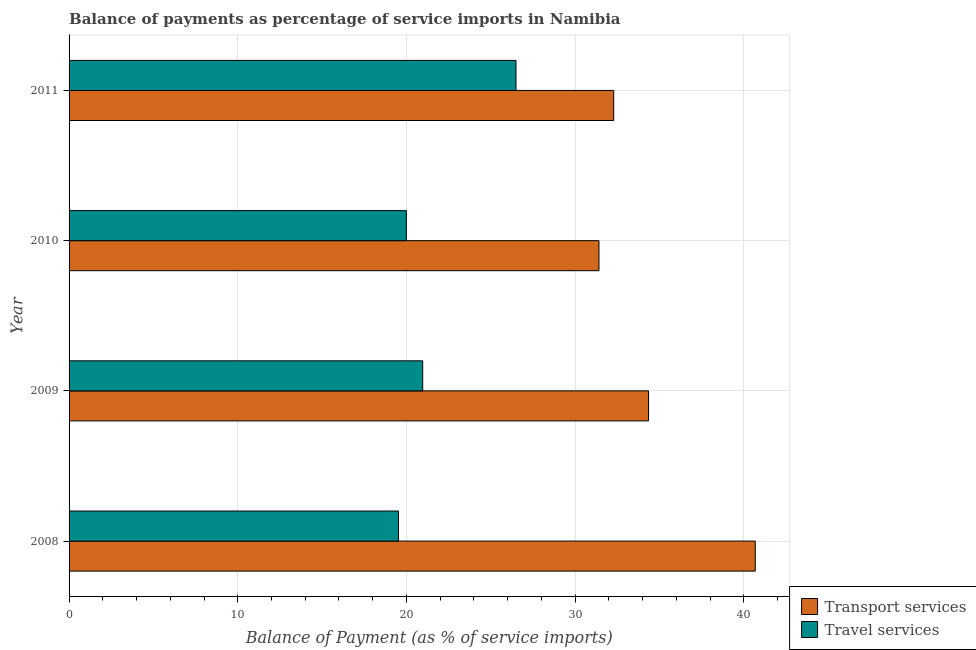How many groups of bars are there?
Provide a short and direct response. 4. Are the number of bars per tick equal to the number of legend labels?
Offer a terse response. Yes. Are the number of bars on each tick of the Y-axis equal?
Ensure brevity in your answer.  Yes. How many bars are there on the 2nd tick from the top?
Your answer should be very brief. 2. What is the balance of payments of transport services in 2009?
Provide a succinct answer. 34.35. Across all years, what is the maximum balance of payments of travel services?
Provide a short and direct response. 26.49. Across all years, what is the minimum balance of payments of transport services?
Offer a terse response. 31.41. In which year was the balance of payments of travel services minimum?
Offer a very short reply. 2008. What is the total balance of payments of transport services in the graph?
Your answer should be very brief. 138.73. What is the difference between the balance of payments of travel services in 2008 and that in 2011?
Your answer should be very brief. -6.96. What is the difference between the balance of payments of travel services in 2008 and the balance of payments of transport services in 2009?
Offer a terse response. -14.82. What is the average balance of payments of travel services per year?
Provide a succinct answer. 21.75. In the year 2008, what is the difference between the balance of payments of travel services and balance of payments of transport services?
Offer a terse response. -21.15. In how many years, is the balance of payments of travel services greater than 12 %?
Give a very brief answer. 4. What is the ratio of the balance of payments of travel services in 2008 to that in 2010?
Provide a short and direct response. 0.98. Is the balance of payments of transport services in 2008 less than that in 2011?
Make the answer very short. No. Is the difference between the balance of payments of transport services in 2009 and 2010 greater than the difference between the balance of payments of travel services in 2009 and 2010?
Your response must be concise. Yes. What is the difference between the highest and the second highest balance of payments of transport services?
Provide a succinct answer. 6.33. What is the difference between the highest and the lowest balance of payments of transport services?
Your answer should be compact. 9.27. In how many years, is the balance of payments of transport services greater than the average balance of payments of transport services taken over all years?
Keep it short and to the point. 1. What does the 2nd bar from the top in 2010 represents?
Make the answer very short. Transport services. What does the 2nd bar from the bottom in 2008 represents?
Your response must be concise. Travel services. Are all the bars in the graph horizontal?
Provide a short and direct response. Yes. How many years are there in the graph?
Your answer should be compact. 4. Does the graph contain grids?
Offer a terse response. Yes. What is the title of the graph?
Provide a succinct answer. Balance of payments as percentage of service imports in Namibia. Does "Overweight" appear as one of the legend labels in the graph?
Your answer should be compact. No. What is the label or title of the X-axis?
Ensure brevity in your answer.  Balance of Payment (as % of service imports). What is the label or title of the Y-axis?
Provide a short and direct response. Year. What is the Balance of Payment (as % of service imports) in Transport services in 2008?
Give a very brief answer. 40.68. What is the Balance of Payment (as % of service imports) of Travel services in 2008?
Keep it short and to the point. 19.53. What is the Balance of Payment (as % of service imports) of Transport services in 2009?
Ensure brevity in your answer.  34.35. What is the Balance of Payment (as % of service imports) of Travel services in 2009?
Your response must be concise. 20.96. What is the Balance of Payment (as % of service imports) in Transport services in 2010?
Offer a terse response. 31.41. What is the Balance of Payment (as % of service imports) of Travel services in 2010?
Your response must be concise. 20. What is the Balance of Payment (as % of service imports) of Transport services in 2011?
Offer a terse response. 32.29. What is the Balance of Payment (as % of service imports) in Travel services in 2011?
Keep it short and to the point. 26.49. Across all years, what is the maximum Balance of Payment (as % of service imports) in Transport services?
Offer a very short reply. 40.68. Across all years, what is the maximum Balance of Payment (as % of service imports) in Travel services?
Your answer should be very brief. 26.49. Across all years, what is the minimum Balance of Payment (as % of service imports) of Transport services?
Offer a very short reply. 31.41. Across all years, what is the minimum Balance of Payment (as % of service imports) in Travel services?
Your response must be concise. 19.53. What is the total Balance of Payment (as % of service imports) in Transport services in the graph?
Offer a terse response. 138.73. What is the total Balance of Payment (as % of service imports) in Travel services in the graph?
Offer a terse response. 86.98. What is the difference between the Balance of Payment (as % of service imports) of Transport services in 2008 and that in 2009?
Offer a very short reply. 6.33. What is the difference between the Balance of Payment (as % of service imports) in Travel services in 2008 and that in 2009?
Provide a short and direct response. -1.43. What is the difference between the Balance of Payment (as % of service imports) of Transport services in 2008 and that in 2010?
Offer a very short reply. 9.27. What is the difference between the Balance of Payment (as % of service imports) of Travel services in 2008 and that in 2010?
Give a very brief answer. -0.47. What is the difference between the Balance of Payment (as % of service imports) of Transport services in 2008 and that in 2011?
Give a very brief answer. 8.39. What is the difference between the Balance of Payment (as % of service imports) of Travel services in 2008 and that in 2011?
Your answer should be very brief. -6.96. What is the difference between the Balance of Payment (as % of service imports) in Transport services in 2009 and that in 2010?
Make the answer very short. 2.94. What is the difference between the Balance of Payment (as % of service imports) of Travel services in 2009 and that in 2010?
Your answer should be very brief. 0.97. What is the difference between the Balance of Payment (as % of service imports) in Transport services in 2009 and that in 2011?
Give a very brief answer. 2.07. What is the difference between the Balance of Payment (as % of service imports) of Travel services in 2009 and that in 2011?
Offer a terse response. -5.53. What is the difference between the Balance of Payment (as % of service imports) in Transport services in 2010 and that in 2011?
Your response must be concise. -0.87. What is the difference between the Balance of Payment (as % of service imports) of Travel services in 2010 and that in 2011?
Offer a very short reply. -6.5. What is the difference between the Balance of Payment (as % of service imports) of Transport services in 2008 and the Balance of Payment (as % of service imports) of Travel services in 2009?
Provide a succinct answer. 19.71. What is the difference between the Balance of Payment (as % of service imports) of Transport services in 2008 and the Balance of Payment (as % of service imports) of Travel services in 2010?
Give a very brief answer. 20.68. What is the difference between the Balance of Payment (as % of service imports) of Transport services in 2008 and the Balance of Payment (as % of service imports) of Travel services in 2011?
Give a very brief answer. 14.18. What is the difference between the Balance of Payment (as % of service imports) of Transport services in 2009 and the Balance of Payment (as % of service imports) of Travel services in 2010?
Make the answer very short. 14.36. What is the difference between the Balance of Payment (as % of service imports) of Transport services in 2009 and the Balance of Payment (as % of service imports) of Travel services in 2011?
Your answer should be very brief. 7.86. What is the difference between the Balance of Payment (as % of service imports) of Transport services in 2010 and the Balance of Payment (as % of service imports) of Travel services in 2011?
Your answer should be very brief. 4.92. What is the average Balance of Payment (as % of service imports) in Transport services per year?
Give a very brief answer. 34.68. What is the average Balance of Payment (as % of service imports) in Travel services per year?
Keep it short and to the point. 21.75. In the year 2008, what is the difference between the Balance of Payment (as % of service imports) of Transport services and Balance of Payment (as % of service imports) of Travel services?
Your response must be concise. 21.15. In the year 2009, what is the difference between the Balance of Payment (as % of service imports) in Transport services and Balance of Payment (as % of service imports) in Travel services?
Offer a terse response. 13.39. In the year 2010, what is the difference between the Balance of Payment (as % of service imports) of Transport services and Balance of Payment (as % of service imports) of Travel services?
Make the answer very short. 11.42. In the year 2011, what is the difference between the Balance of Payment (as % of service imports) in Transport services and Balance of Payment (as % of service imports) in Travel services?
Give a very brief answer. 5.79. What is the ratio of the Balance of Payment (as % of service imports) in Transport services in 2008 to that in 2009?
Offer a very short reply. 1.18. What is the ratio of the Balance of Payment (as % of service imports) of Travel services in 2008 to that in 2009?
Offer a very short reply. 0.93. What is the ratio of the Balance of Payment (as % of service imports) in Transport services in 2008 to that in 2010?
Your response must be concise. 1.29. What is the ratio of the Balance of Payment (as % of service imports) of Travel services in 2008 to that in 2010?
Provide a succinct answer. 0.98. What is the ratio of the Balance of Payment (as % of service imports) of Transport services in 2008 to that in 2011?
Keep it short and to the point. 1.26. What is the ratio of the Balance of Payment (as % of service imports) of Travel services in 2008 to that in 2011?
Keep it short and to the point. 0.74. What is the ratio of the Balance of Payment (as % of service imports) of Transport services in 2009 to that in 2010?
Offer a very short reply. 1.09. What is the ratio of the Balance of Payment (as % of service imports) of Travel services in 2009 to that in 2010?
Offer a terse response. 1.05. What is the ratio of the Balance of Payment (as % of service imports) in Transport services in 2009 to that in 2011?
Give a very brief answer. 1.06. What is the ratio of the Balance of Payment (as % of service imports) in Travel services in 2009 to that in 2011?
Make the answer very short. 0.79. What is the ratio of the Balance of Payment (as % of service imports) in Transport services in 2010 to that in 2011?
Make the answer very short. 0.97. What is the ratio of the Balance of Payment (as % of service imports) in Travel services in 2010 to that in 2011?
Your answer should be compact. 0.75. What is the difference between the highest and the second highest Balance of Payment (as % of service imports) in Transport services?
Your answer should be very brief. 6.33. What is the difference between the highest and the second highest Balance of Payment (as % of service imports) of Travel services?
Offer a very short reply. 5.53. What is the difference between the highest and the lowest Balance of Payment (as % of service imports) in Transport services?
Your answer should be compact. 9.27. What is the difference between the highest and the lowest Balance of Payment (as % of service imports) in Travel services?
Keep it short and to the point. 6.96. 